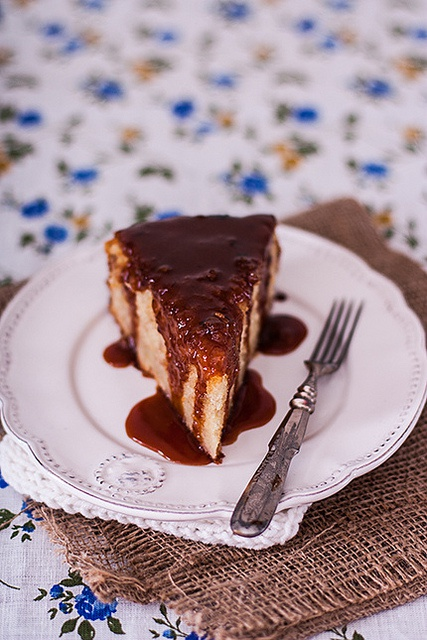Describe the objects in this image and their specific colors. I can see dining table in lavender, darkgray, lightgray, maroon, and black tones, cake in gray, maroon, black, tan, and brown tones, and fork in gray, black, and darkgray tones in this image. 